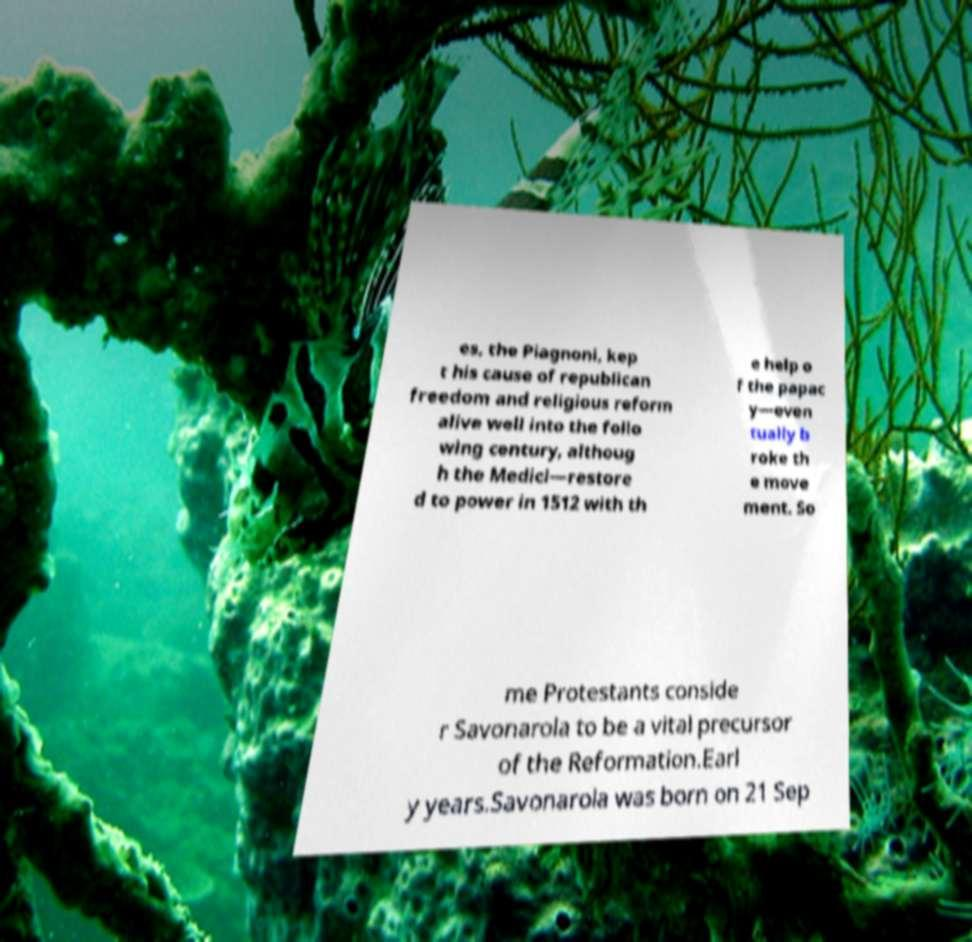There's text embedded in this image that I need extracted. Can you transcribe it verbatim? es, the Piagnoni, kep t his cause of republican freedom and religious reform alive well into the follo wing century, althoug h the Medici—restore d to power in 1512 with th e help o f the papac y—even tually b roke th e move ment. So me Protestants conside r Savonarola to be a vital precursor of the Reformation.Earl y years.Savonarola was born on 21 Sep 